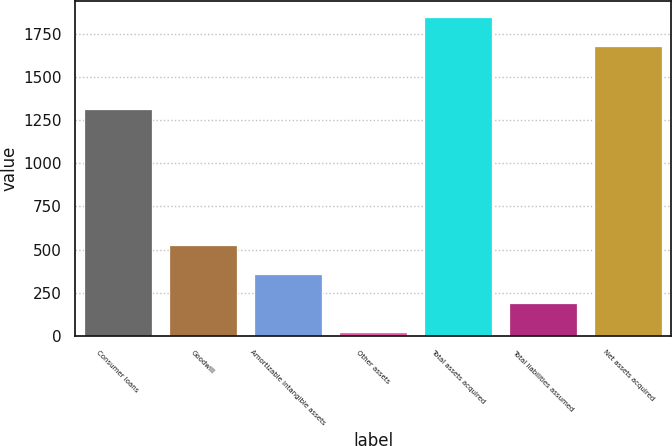<chart> <loc_0><loc_0><loc_500><loc_500><bar_chart><fcel>Consumer loans<fcel>Goodwill<fcel>Amortizable intangible assets<fcel>Other assets<fcel>Total assets acquired<fcel>Total liabilities assumed<fcel>Net assets acquired<nl><fcel>1316<fcel>525.8<fcel>357.2<fcel>20<fcel>1844.6<fcel>188.6<fcel>1676<nl></chart> 